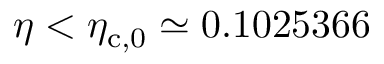Convert formula to latex. <formula><loc_0><loc_0><loc_500><loc_500>\eta < \eta _ { c , 0 } \simeq 0 . 1 0 2 5 3 6 6</formula> 